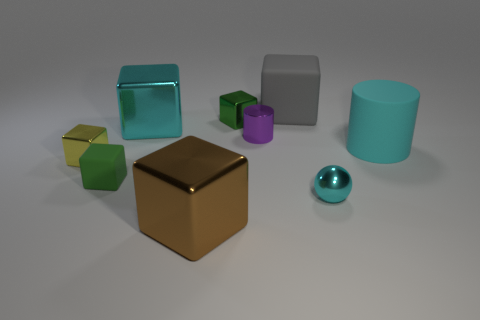Subtract all shiny blocks. How many blocks are left? 2 Add 1 red rubber balls. How many objects exist? 10 Subtract all purple cylinders. How many cylinders are left? 1 Subtract 2 cylinders. How many cylinders are left? 0 Subtract all cubes. How many objects are left? 3 Subtract all green cylinders. How many cyan blocks are left? 1 Subtract 0 brown balls. How many objects are left? 9 Subtract all green cubes. Subtract all cyan cylinders. How many cubes are left? 4 Subtract all big gray matte balls. Subtract all brown things. How many objects are left? 8 Add 1 tiny green objects. How many tiny green objects are left? 3 